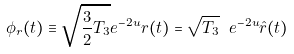<formula> <loc_0><loc_0><loc_500><loc_500>\phi _ { r } ( t ) \equiv \sqrt { \frac { 3 } { 2 } T _ { 3 } } e ^ { - 2 u } r ( t ) = \sqrt { T _ { 3 } } \ e ^ { - 2 u } \hat { r } ( t )</formula> 